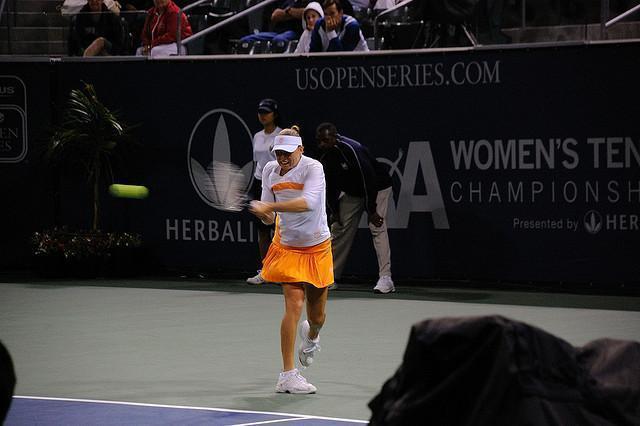Where is this tournament based?
Choose the right answer and clarify with the format: 'Answer: answer
Rationale: rationale.'
Options: London, flushing meadows, poughkeepsie, little rock. Answer: flushing meadows.
Rationale: The name of the tournament is located on the wall in the background and the location is internet searchable. 